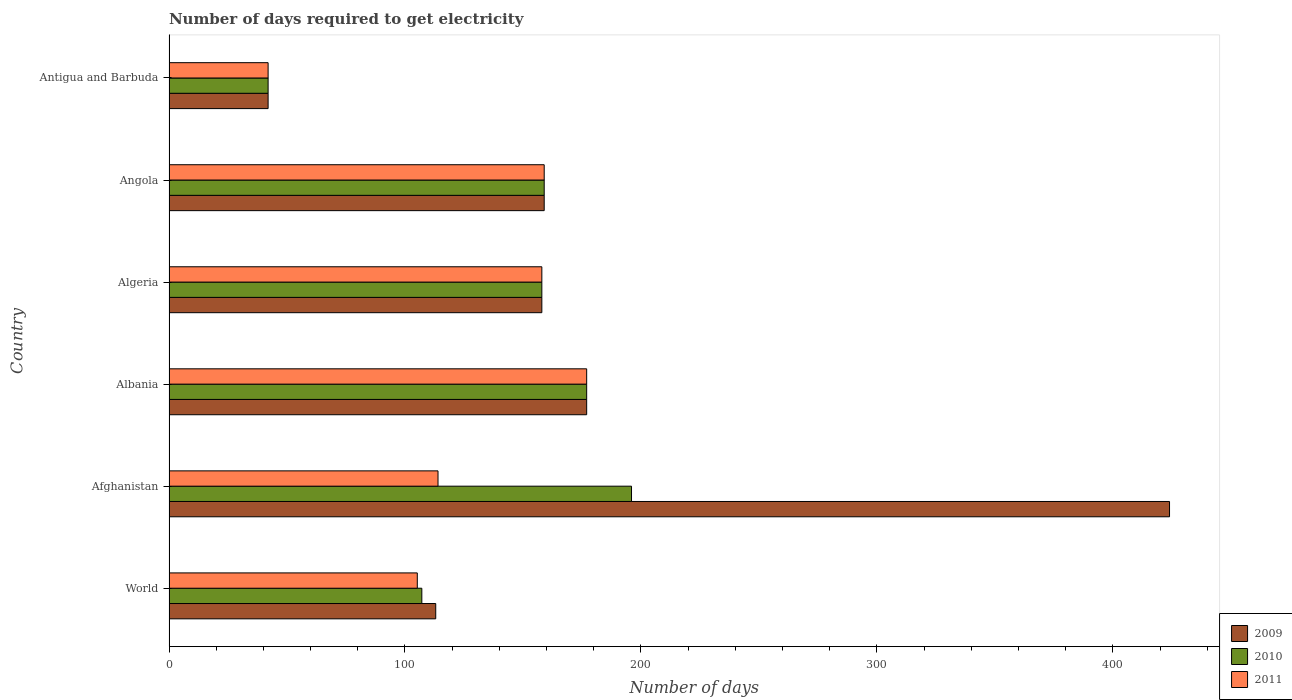How many different coloured bars are there?
Provide a succinct answer. 3. How many groups of bars are there?
Offer a very short reply. 6. Are the number of bars per tick equal to the number of legend labels?
Ensure brevity in your answer.  Yes. Are the number of bars on each tick of the Y-axis equal?
Ensure brevity in your answer.  Yes. How many bars are there on the 3rd tick from the bottom?
Provide a succinct answer. 3. What is the label of the 2nd group of bars from the top?
Give a very brief answer. Angola. What is the number of days required to get electricity in in 2011 in Angola?
Ensure brevity in your answer.  159. Across all countries, what is the maximum number of days required to get electricity in in 2009?
Make the answer very short. 424. In which country was the number of days required to get electricity in in 2011 maximum?
Offer a terse response. Albania. In which country was the number of days required to get electricity in in 2009 minimum?
Your response must be concise. Antigua and Barbuda. What is the total number of days required to get electricity in in 2010 in the graph?
Offer a terse response. 839.15. What is the difference between the number of days required to get electricity in in 2010 in Afghanistan and that in World?
Offer a very short reply. 88.85. What is the average number of days required to get electricity in in 2009 per country?
Give a very brief answer. 178.84. In how many countries, is the number of days required to get electricity in in 2009 greater than 100 days?
Give a very brief answer. 5. What is the ratio of the number of days required to get electricity in in 2011 in Albania to that in Angola?
Offer a very short reply. 1.11. Is the number of days required to get electricity in in 2009 in Albania less than that in Algeria?
Keep it short and to the point. No. Is the difference between the number of days required to get electricity in in 2009 in Albania and Algeria greater than the difference between the number of days required to get electricity in in 2011 in Albania and Algeria?
Offer a very short reply. No. What is the difference between the highest and the second highest number of days required to get electricity in in 2011?
Offer a terse response. 18. What is the difference between the highest and the lowest number of days required to get electricity in in 2010?
Provide a succinct answer. 154. Is the sum of the number of days required to get electricity in in 2009 in Algeria and Antigua and Barbuda greater than the maximum number of days required to get electricity in in 2010 across all countries?
Give a very brief answer. Yes. What does the 1st bar from the top in Angola represents?
Keep it short and to the point. 2011. What does the 1st bar from the bottom in World represents?
Keep it short and to the point. 2009. Is it the case that in every country, the sum of the number of days required to get electricity in in 2010 and number of days required to get electricity in in 2011 is greater than the number of days required to get electricity in in 2009?
Make the answer very short. No. How many bars are there?
Provide a succinct answer. 18. Are all the bars in the graph horizontal?
Provide a short and direct response. Yes. How many countries are there in the graph?
Provide a short and direct response. 6. Are the values on the major ticks of X-axis written in scientific E-notation?
Your answer should be very brief. No. Does the graph contain any zero values?
Give a very brief answer. No. Where does the legend appear in the graph?
Make the answer very short. Bottom right. How many legend labels are there?
Keep it short and to the point. 3. What is the title of the graph?
Keep it short and to the point. Number of days required to get electricity. Does "1976" appear as one of the legend labels in the graph?
Provide a succinct answer. No. What is the label or title of the X-axis?
Keep it short and to the point. Number of days. What is the label or title of the Y-axis?
Your answer should be compact. Country. What is the Number of days of 2009 in World?
Give a very brief answer. 113.03. What is the Number of days of 2010 in World?
Your response must be concise. 107.15. What is the Number of days in 2011 in World?
Give a very brief answer. 105.22. What is the Number of days of 2009 in Afghanistan?
Ensure brevity in your answer.  424. What is the Number of days of 2010 in Afghanistan?
Your response must be concise. 196. What is the Number of days of 2011 in Afghanistan?
Your response must be concise. 114. What is the Number of days of 2009 in Albania?
Offer a terse response. 177. What is the Number of days of 2010 in Albania?
Keep it short and to the point. 177. What is the Number of days in 2011 in Albania?
Offer a terse response. 177. What is the Number of days of 2009 in Algeria?
Your response must be concise. 158. What is the Number of days in 2010 in Algeria?
Offer a very short reply. 158. What is the Number of days of 2011 in Algeria?
Offer a very short reply. 158. What is the Number of days of 2009 in Angola?
Provide a succinct answer. 159. What is the Number of days of 2010 in Angola?
Give a very brief answer. 159. What is the Number of days of 2011 in Angola?
Ensure brevity in your answer.  159. What is the Number of days in 2009 in Antigua and Barbuda?
Your response must be concise. 42. What is the Number of days of 2010 in Antigua and Barbuda?
Offer a terse response. 42. Across all countries, what is the maximum Number of days of 2009?
Your response must be concise. 424. Across all countries, what is the maximum Number of days of 2010?
Offer a terse response. 196. Across all countries, what is the maximum Number of days of 2011?
Provide a succinct answer. 177. Across all countries, what is the minimum Number of days of 2009?
Your answer should be compact. 42. Across all countries, what is the minimum Number of days of 2010?
Offer a terse response. 42. Across all countries, what is the minimum Number of days in 2011?
Keep it short and to the point. 42. What is the total Number of days of 2009 in the graph?
Provide a short and direct response. 1073.03. What is the total Number of days in 2010 in the graph?
Give a very brief answer. 839.15. What is the total Number of days of 2011 in the graph?
Provide a short and direct response. 755.22. What is the difference between the Number of days of 2009 in World and that in Afghanistan?
Keep it short and to the point. -310.97. What is the difference between the Number of days in 2010 in World and that in Afghanistan?
Provide a short and direct response. -88.85. What is the difference between the Number of days in 2011 in World and that in Afghanistan?
Offer a terse response. -8.78. What is the difference between the Number of days of 2009 in World and that in Albania?
Your answer should be very brief. -63.97. What is the difference between the Number of days in 2010 in World and that in Albania?
Ensure brevity in your answer.  -69.85. What is the difference between the Number of days of 2011 in World and that in Albania?
Ensure brevity in your answer.  -71.78. What is the difference between the Number of days of 2009 in World and that in Algeria?
Offer a very short reply. -44.97. What is the difference between the Number of days in 2010 in World and that in Algeria?
Offer a very short reply. -50.85. What is the difference between the Number of days of 2011 in World and that in Algeria?
Offer a terse response. -52.78. What is the difference between the Number of days of 2009 in World and that in Angola?
Your answer should be very brief. -45.97. What is the difference between the Number of days in 2010 in World and that in Angola?
Offer a very short reply. -51.85. What is the difference between the Number of days of 2011 in World and that in Angola?
Make the answer very short. -53.78. What is the difference between the Number of days of 2009 in World and that in Antigua and Barbuda?
Provide a short and direct response. 71.03. What is the difference between the Number of days of 2010 in World and that in Antigua and Barbuda?
Offer a very short reply. 65.15. What is the difference between the Number of days in 2011 in World and that in Antigua and Barbuda?
Keep it short and to the point. 63.22. What is the difference between the Number of days in 2009 in Afghanistan and that in Albania?
Provide a short and direct response. 247. What is the difference between the Number of days in 2011 in Afghanistan and that in Albania?
Keep it short and to the point. -63. What is the difference between the Number of days of 2009 in Afghanistan and that in Algeria?
Your answer should be compact. 266. What is the difference between the Number of days in 2010 in Afghanistan and that in Algeria?
Offer a terse response. 38. What is the difference between the Number of days in 2011 in Afghanistan and that in Algeria?
Keep it short and to the point. -44. What is the difference between the Number of days in 2009 in Afghanistan and that in Angola?
Give a very brief answer. 265. What is the difference between the Number of days of 2011 in Afghanistan and that in Angola?
Ensure brevity in your answer.  -45. What is the difference between the Number of days of 2009 in Afghanistan and that in Antigua and Barbuda?
Make the answer very short. 382. What is the difference between the Number of days of 2010 in Afghanistan and that in Antigua and Barbuda?
Your answer should be very brief. 154. What is the difference between the Number of days of 2011 in Afghanistan and that in Antigua and Barbuda?
Offer a terse response. 72. What is the difference between the Number of days of 2009 in Albania and that in Algeria?
Provide a succinct answer. 19. What is the difference between the Number of days of 2010 in Albania and that in Algeria?
Provide a succinct answer. 19. What is the difference between the Number of days of 2009 in Albania and that in Angola?
Ensure brevity in your answer.  18. What is the difference between the Number of days of 2009 in Albania and that in Antigua and Barbuda?
Your answer should be very brief. 135. What is the difference between the Number of days in 2010 in Albania and that in Antigua and Barbuda?
Ensure brevity in your answer.  135. What is the difference between the Number of days in 2011 in Albania and that in Antigua and Barbuda?
Ensure brevity in your answer.  135. What is the difference between the Number of days in 2010 in Algeria and that in Angola?
Provide a short and direct response. -1. What is the difference between the Number of days in 2009 in Algeria and that in Antigua and Barbuda?
Ensure brevity in your answer.  116. What is the difference between the Number of days in 2010 in Algeria and that in Antigua and Barbuda?
Offer a very short reply. 116. What is the difference between the Number of days in 2011 in Algeria and that in Antigua and Barbuda?
Your response must be concise. 116. What is the difference between the Number of days of 2009 in Angola and that in Antigua and Barbuda?
Offer a very short reply. 117. What is the difference between the Number of days of 2010 in Angola and that in Antigua and Barbuda?
Offer a terse response. 117. What is the difference between the Number of days in 2011 in Angola and that in Antigua and Barbuda?
Your answer should be compact. 117. What is the difference between the Number of days in 2009 in World and the Number of days in 2010 in Afghanistan?
Provide a succinct answer. -82.97. What is the difference between the Number of days in 2009 in World and the Number of days in 2011 in Afghanistan?
Provide a succinct answer. -0.97. What is the difference between the Number of days in 2010 in World and the Number of days in 2011 in Afghanistan?
Give a very brief answer. -6.85. What is the difference between the Number of days in 2009 in World and the Number of days in 2010 in Albania?
Keep it short and to the point. -63.97. What is the difference between the Number of days of 2009 in World and the Number of days of 2011 in Albania?
Provide a succinct answer. -63.97. What is the difference between the Number of days in 2010 in World and the Number of days in 2011 in Albania?
Your answer should be very brief. -69.85. What is the difference between the Number of days in 2009 in World and the Number of days in 2010 in Algeria?
Your answer should be compact. -44.97. What is the difference between the Number of days of 2009 in World and the Number of days of 2011 in Algeria?
Your answer should be very brief. -44.97. What is the difference between the Number of days in 2010 in World and the Number of days in 2011 in Algeria?
Ensure brevity in your answer.  -50.85. What is the difference between the Number of days of 2009 in World and the Number of days of 2010 in Angola?
Make the answer very short. -45.97. What is the difference between the Number of days in 2009 in World and the Number of days in 2011 in Angola?
Your answer should be compact. -45.97. What is the difference between the Number of days of 2010 in World and the Number of days of 2011 in Angola?
Your response must be concise. -51.85. What is the difference between the Number of days in 2009 in World and the Number of days in 2010 in Antigua and Barbuda?
Your answer should be compact. 71.03. What is the difference between the Number of days in 2009 in World and the Number of days in 2011 in Antigua and Barbuda?
Give a very brief answer. 71.03. What is the difference between the Number of days in 2010 in World and the Number of days in 2011 in Antigua and Barbuda?
Your answer should be very brief. 65.15. What is the difference between the Number of days in 2009 in Afghanistan and the Number of days in 2010 in Albania?
Keep it short and to the point. 247. What is the difference between the Number of days in 2009 in Afghanistan and the Number of days in 2011 in Albania?
Your answer should be compact. 247. What is the difference between the Number of days in 2009 in Afghanistan and the Number of days in 2010 in Algeria?
Provide a succinct answer. 266. What is the difference between the Number of days in 2009 in Afghanistan and the Number of days in 2011 in Algeria?
Your answer should be compact. 266. What is the difference between the Number of days of 2010 in Afghanistan and the Number of days of 2011 in Algeria?
Offer a terse response. 38. What is the difference between the Number of days of 2009 in Afghanistan and the Number of days of 2010 in Angola?
Provide a short and direct response. 265. What is the difference between the Number of days in 2009 in Afghanistan and the Number of days in 2011 in Angola?
Give a very brief answer. 265. What is the difference between the Number of days of 2009 in Afghanistan and the Number of days of 2010 in Antigua and Barbuda?
Provide a short and direct response. 382. What is the difference between the Number of days in 2009 in Afghanistan and the Number of days in 2011 in Antigua and Barbuda?
Offer a very short reply. 382. What is the difference between the Number of days of 2010 in Afghanistan and the Number of days of 2011 in Antigua and Barbuda?
Provide a succinct answer. 154. What is the difference between the Number of days of 2009 in Albania and the Number of days of 2010 in Algeria?
Your response must be concise. 19. What is the difference between the Number of days of 2010 in Albania and the Number of days of 2011 in Algeria?
Give a very brief answer. 19. What is the difference between the Number of days in 2009 in Albania and the Number of days in 2010 in Angola?
Provide a succinct answer. 18. What is the difference between the Number of days in 2010 in Albania and the Number of days in 2011 in Angola?
Your answer should be very brief. 18. What is the difference between the Number of days of 2009 in Albania and the Number of days of 2010 in Antigua and Barbuda?
Your answer should be very brief. 135. What is the difference between the Number of days in 2009 in Albania and the Number of days in 2011 in Antigua and Barbuda?
Provide a short and direct response. 135. What is the difference between the Number of days in 2010 in Albania and the Number of days in 2011 in Antigua and Barbuda?
Keep it short and to the point. 135. What is the difference between the Number of days of 2009 in Algeria and the Number of days of 2010 in Angola?
Offer a very short reply. -1. What is the difference between the Number of days of 2009 in Algeria and the Number of days of 2011 in Angola?
Your response must be concise. -1. What is the difference between the Number of days in 2010 in Algeria and the Number of days in 2011 in Angola?
Your answer should be very brief. -1. What is the difference between the Number of days in 2009 in Algeria and the Number of days in 2010 in Antigua and Barbuda?
Provide a short and direct response. 116. What is the difference between the Number of days in 2009 in Algeria and the Number of days in 2011 in Antigua and Barbuda?
Give a very brief answer. 116. What is the difference between the Number of days of 2010 in Algeria and the Number of days of 2011 in Antigua and Barbuda?
Your answer should be compact. 116. What is the difference between the Number of days in 2009 in Angola and the Number of days in 2010 in Antigua and Barbuda?
Your answer should be compact. 117. What is the difference between the Number of days in 2009 in Angola and the Number of days in 2011 in Antigua and Barbuda?
Provide a succinct answer. 117. What is the difference between the Number of days in 2010 in Angola and the Number of days in 2011 in Antigua and Barbuda?
Provide a succinct answer. 117. What is the average Number of days of 2009 per country?
Your answer should be compact. 178.84. What is the average Number of days of 2010 per country?
Make the answer very short. 139.86. What is the average Number of days in 2011 per country?
Offer a terse response. 125.87. What is the difference between the Number of days in 2009 and Number of days in 2010 in World?
Offer a very short reply. 5.89. What is the difference between the Number of days of 2009 and Number of days of 2011 in World?
Offer a terse response. 7.81. What is the difference between the Number of days in 2010 and Number of days in 2011 in World?
Your answer should be compact. 1.92. What is the difference between the Number of days in 2009 and Number of days in 2010 in Afghanistan?
Ensure brevity in your answer.  228. What is the difference between the Number of days of 2009 and Number of days of 2011 in Afghanistan?
Provide a short and direct response. 310. What is the difference between the Number of days of 2009 and Number of days of 2010 in Albania?
Give a very brief answer. 0. What is the difference between the Number of days of 2009 and Number of days of 2010 in Algeria?
Ensure brevity in your answer.  0. What is the difference between the Number of days of 2009 and Number of days of 2011 in Angola?
Your answer should be compact. 0. What is the difference between the Number of days of 2010 and Number of days of 2011 in Angola?
Provide a short and direct response. 0. What is the difference between the Number of days of 2009 and Number of days of 2010 in Antigua and Barbuda?
Your response must be concise. 0. What is the difference between the Number of days of 2009 and Number of days of 2011 in Antigua and Barbuda?
Give a very brief answer. 0. What is the difference between the Number of days in 2010 and Number of days in 2011 in Antigua and Barbuda?
Ensure brevity in your answer.  0. What is the ratio of the Number of days in 2009 in World to that in Afghanistan?
Give a very brief answer. 0.27. What is the ratio of the Number of days in 2010 in World to that in Afghanistan?
Your answer should be very brief. 0.55. What is the ratio of the Number of days in 2011 in World to that in Afghanistan?
Keep it short and to the point. 0.92. What is the ratio of the Number of days of 2009 in World to that in Albania?
Provide a succinct answer. 0.64. What is the ratio of the Number of days in 2010 in World to that in Albania?
Give a very brief answer. 0.61. What is the ratio of the Number of days of 2011 in World to that in Albania?
Keep it short and to the point. 0.59. What is the ratio of the Number of days in 2009 in World to that in Algeria?
Make the answer very short. 0.72. What is the ratio of the Number of days of 2010 in World to that in Algeria?
Keep it short and to the point. 0.68. What is the ratio of the Number of days in 2011 in World to that in Algeria?
Offer a terse response. 0.67. What is the ratio of the Number of days in 2009 in World to that in Angola?
Your response must be concise. 0.71. What is the ratio of the Number of days in 2010 in World to that in Angola?
Offer a terse response. 0.67. What is the ratio of the Number of days in 2011 in World to that in Angola?
Ensure brevity in your answer.  0.66. What is the ratio of the Number of days of 2009 in World to that in Antigua and Barbuda?
Keep it short and to the point. 2.69. What is the ratio of the Number of days of 2010 in World to that in Antigua and Barbuda?
Offer a terse response. 2.55. What is the ratio of the Number of days in 2011 in World to that in Antigua and Barbuda?
Offer a very short reply. 2.51. What is the ratio of the Number of days of 2009 in Afghanistan to that in Albania?
Provide a short and direct response. 2.4. What is the ratio of the Number of days of 2010 in Afghanistan to that in Albania?
Ensure brevity in your answer.  1.11. What is the ratio of the Number of days in 2011 in Afghanistan to that in Albania?
Offer a terse response. 0.64. What is the ratio of the Number of days in 2009 in Afghanistan to that in Algeria?
Ensure brevity in your answer.  2.68. What is the ratio of the Number of days of 2010 in Afghanistan to that in Algeria?
Provide a short and direct response. 1.24. What is the ratio of the Number of days in 2011 in Afghanistan to that in Algeria?
Ensure brevity in your answer.  0.72. What is the ratio of the Number of days of 2009 in Afghanistan to that in Angola?
Ensure brevity in your answer.  2.67. What is the ratio of the Number of days of 2010 in Afghanistan to that in Angola?
Offer a very short reply. 1.23. What is the ratio of the Number of days in 2011 in Afghanistan to that in Angola?
Your answer should be compact. 0.72. What is the ratio of the Number of days of 2009 in Afghanistan to that in Antigua and Barbuda?
Your answer should be very brief. 10.1. What is the ratio of the Number of days of 2010 in Afghanistan to that in Antigua and Barbuda?
Give a very brief answer. 4.67. What is the ratio of the Number of days in 2011 in Afghanistan to that in Antigua and Barbuda?
Offer a terse response. 2.71. What is the ratio of the Number of days in 2009 in Albania to that in Algeria?
Offer a terse response. 1.12. What is the ratio of the Number of days of 2010 in Albania to that in Algeria?
Provide a succinct answer. 1.12. What is the ratio of the Number of days in 2011 in Albania to that in Algeria?
Keep it short and to the point. 1.12. What is the ratio of the Number of days in 2009 in Albania to that in Angola?
Your answer should be compact. 1.11. What is the ratio of the Number of days in 2010 in Albania to that in Angola?
Offer a very short reply. 1.11. What is the ratio of the Number of days of 2011 in Albania to that in Angola?
Make the answer very short. 1.11. What is the ratio of the Number of days in 2009 in Albania to that in Antigua and Barbuda?
Your answer should be very brief. 4.21. What is the ratio of the Number of days in 2010 in Albania to that in Antigua and Barbuda?
Ensure brevity in your answer.  4.21. What is the ratio of the Number of days in 2011 in Albania to that in Antigua and Barbuda?
Offer a terse response. 4.21. What is the ratio of the Number of days in 2011 in Algeria to that in Angola?
Give a very brief answer. 0.99. What is the ratio of the Number of days of 2009 in Algeria to that in Antigua and Barbuda?
Your response must be concise. 3.76. What is the ratio of the Number of days of 2010 in Algeria to that in Antigua and Barbuda?
Offer a very short reply. 3.76. What is the ratio of the Number of days of 2011 in Algeria to that in Antigua and Barbuda?
Your answer should be very brief. 3.76. What is the ratio of the Number of days of 2009 in Angola to that in Antigua and Barbuda?
Give a very brief answer. 3.79. What is the ratio of the Number of days of 2010 in Angola to that in Antigua and Barbuda?
Give a very brief answer. 3.79. What is the ratio of the Number of days of 2011 in Angola to that in Antigua and Barbuda?
Your response must be concise. 3.79. What is the difference between the highest and the second highest Number of days of 2009?
Provide a succinct answer. 247. What is the difference between the highest and the second highest Number of days of 2010?
Keep it short and to the point. 19. What is the difference between the highest and the second highest Number of days of 2011?
Your response must be concise. 18. What is the difference between the highest and the lowest Number of days in 2009?
Offer a very short reply. 382. What is the difference between the highest and the lowest Number of days of 2010?
Keep it short and to the point. 154. What is the difference between the highest and the lowest Number of days in 2011?
Ensure brevity in your answer.  135. 